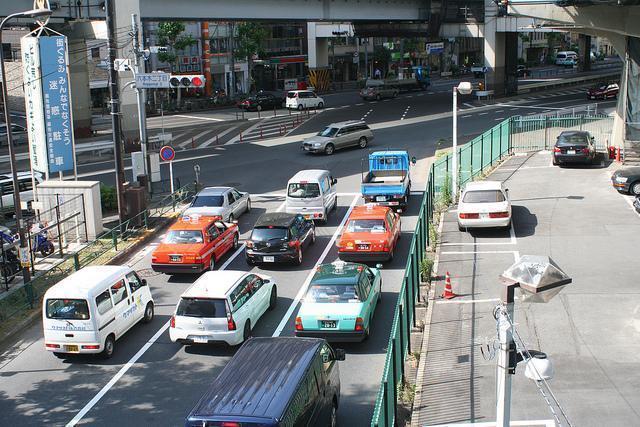What make is the white vehicle to the left of the green white cab?
Indicate the correct choice and explain in the format: 'Answer: answer
Rationale: rationale.'
Options: Mitsubishi, lexus, audi, ford. Answer: mitsubishi.
Rationale: Its three-diamond logo is visible on the back. 